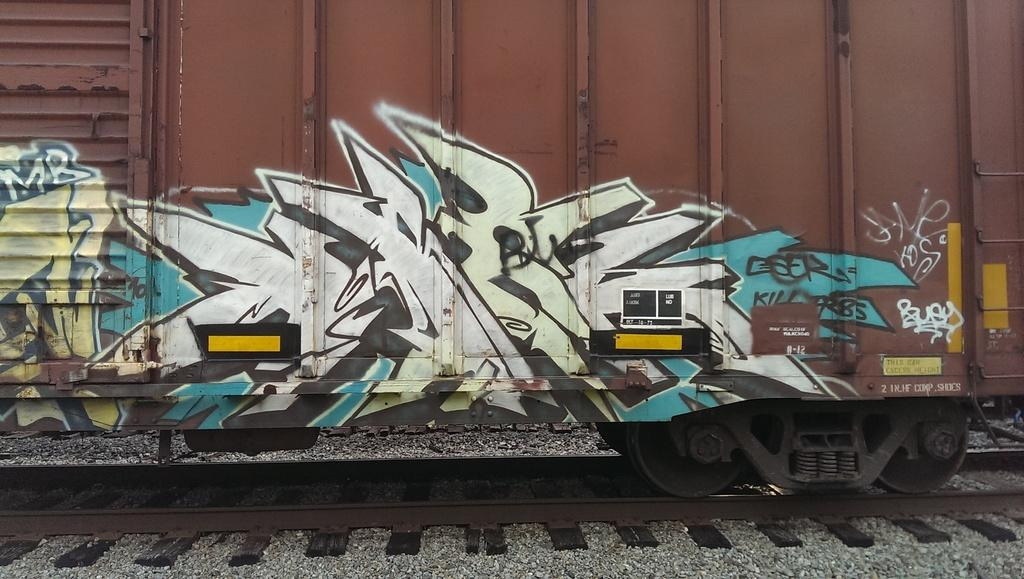What is depicted on the train in the image? There is Graffiti on a train in the image. Where is the train located? The train is on a track. What type of terrain is visible in the image? There are stones visible in the image. What is the taste of the rose in the image? There is no rose present in the image, so it is not possible to determine its taste. 